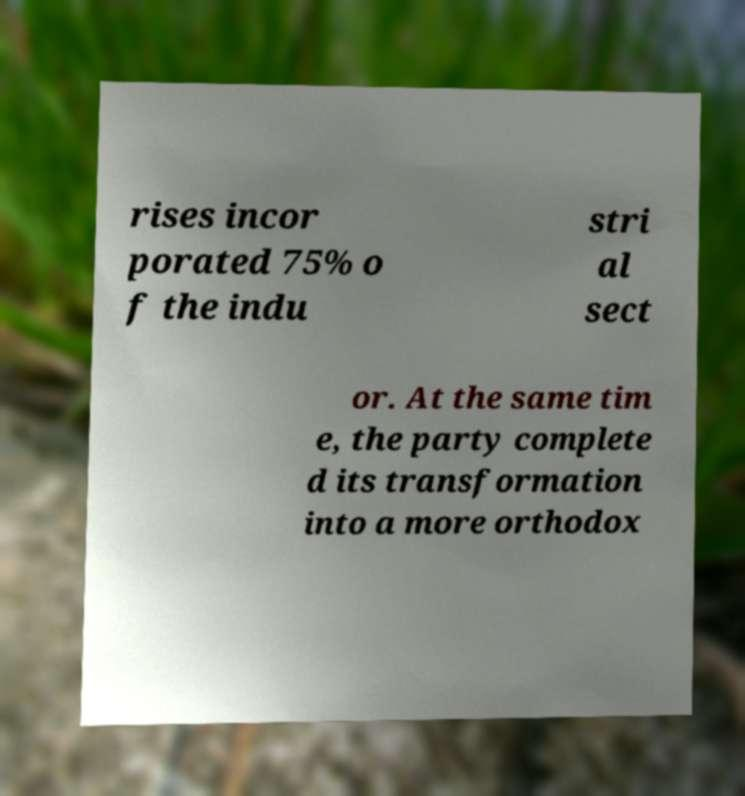Could you assist in decoding the text presented in this image and type it out clearly? rises incor porated 75% o f the indu stri al sect or. At the same tim e, the party complete d its transformation into a more orthodox 